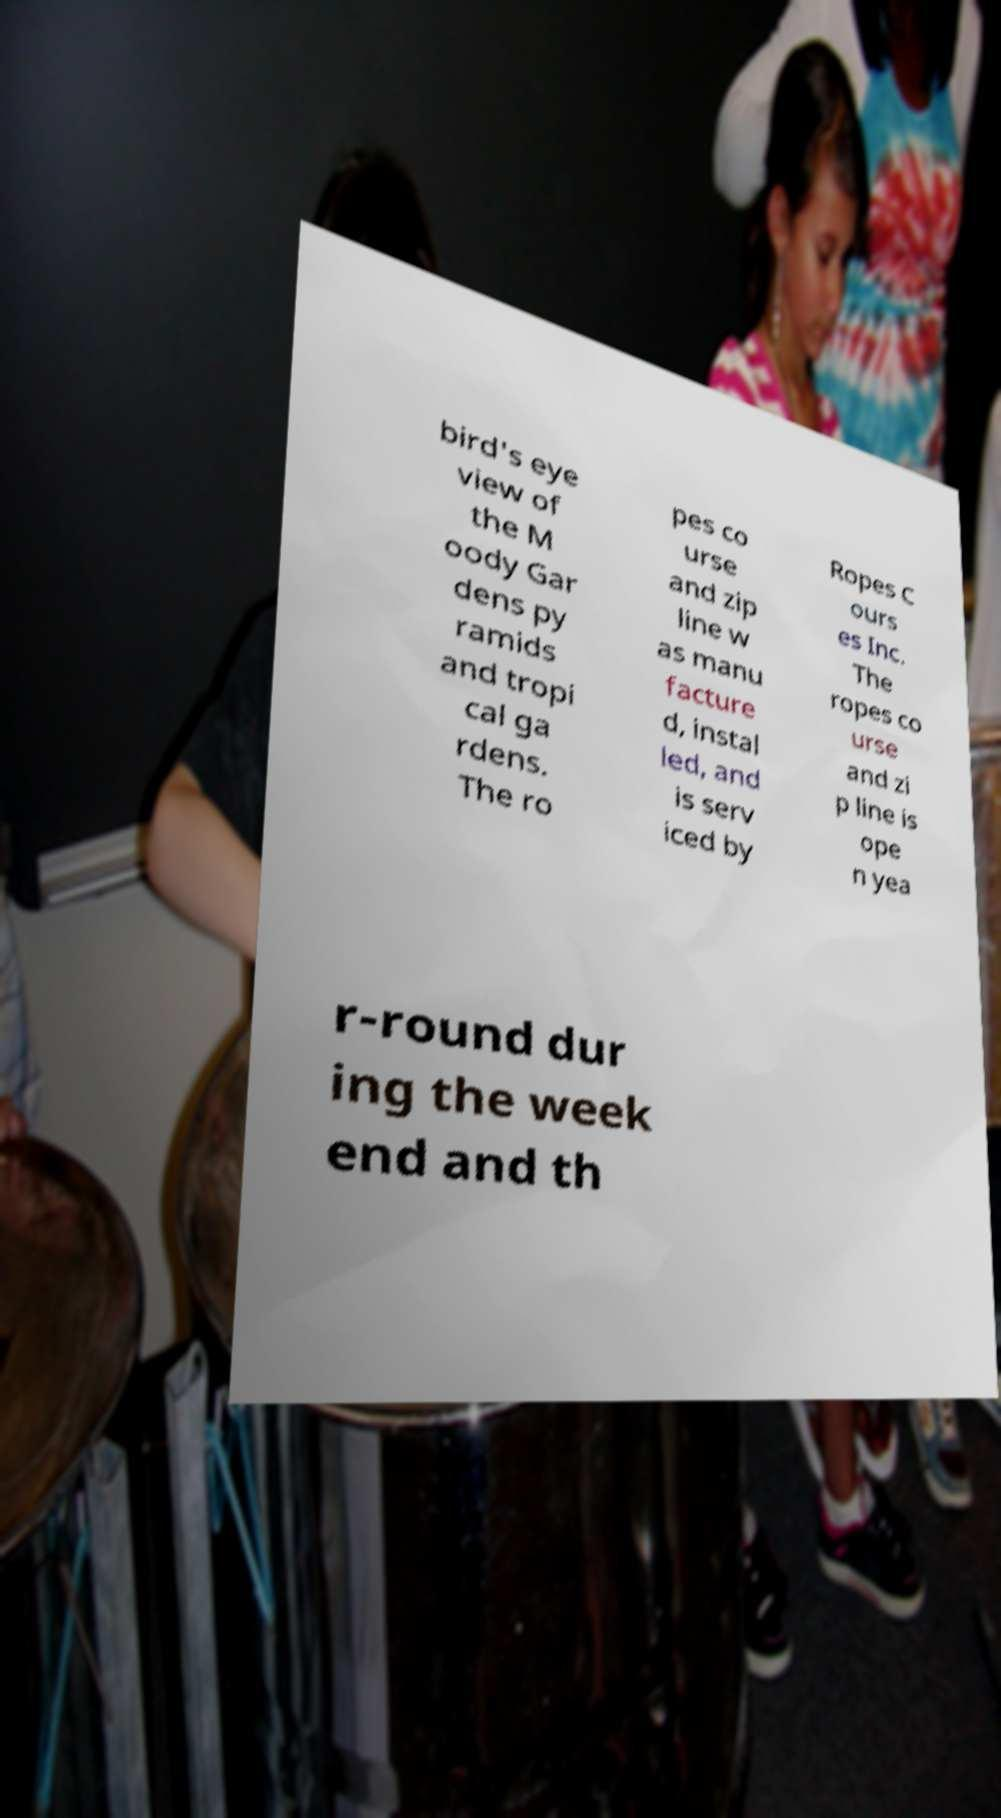There's text embedded in this image that I need extracted. Can you transcribe it verbatim? bird's eye view of the M oody Gar dens py ramids and tropi cal ga rdens. The ro pes co urse and zip line w as manu facture d, instal led, and is serv iced by Ropes C ours es Inc. The ropes co urse and zi p line is ope n yea r-round dur ing the week end and th 